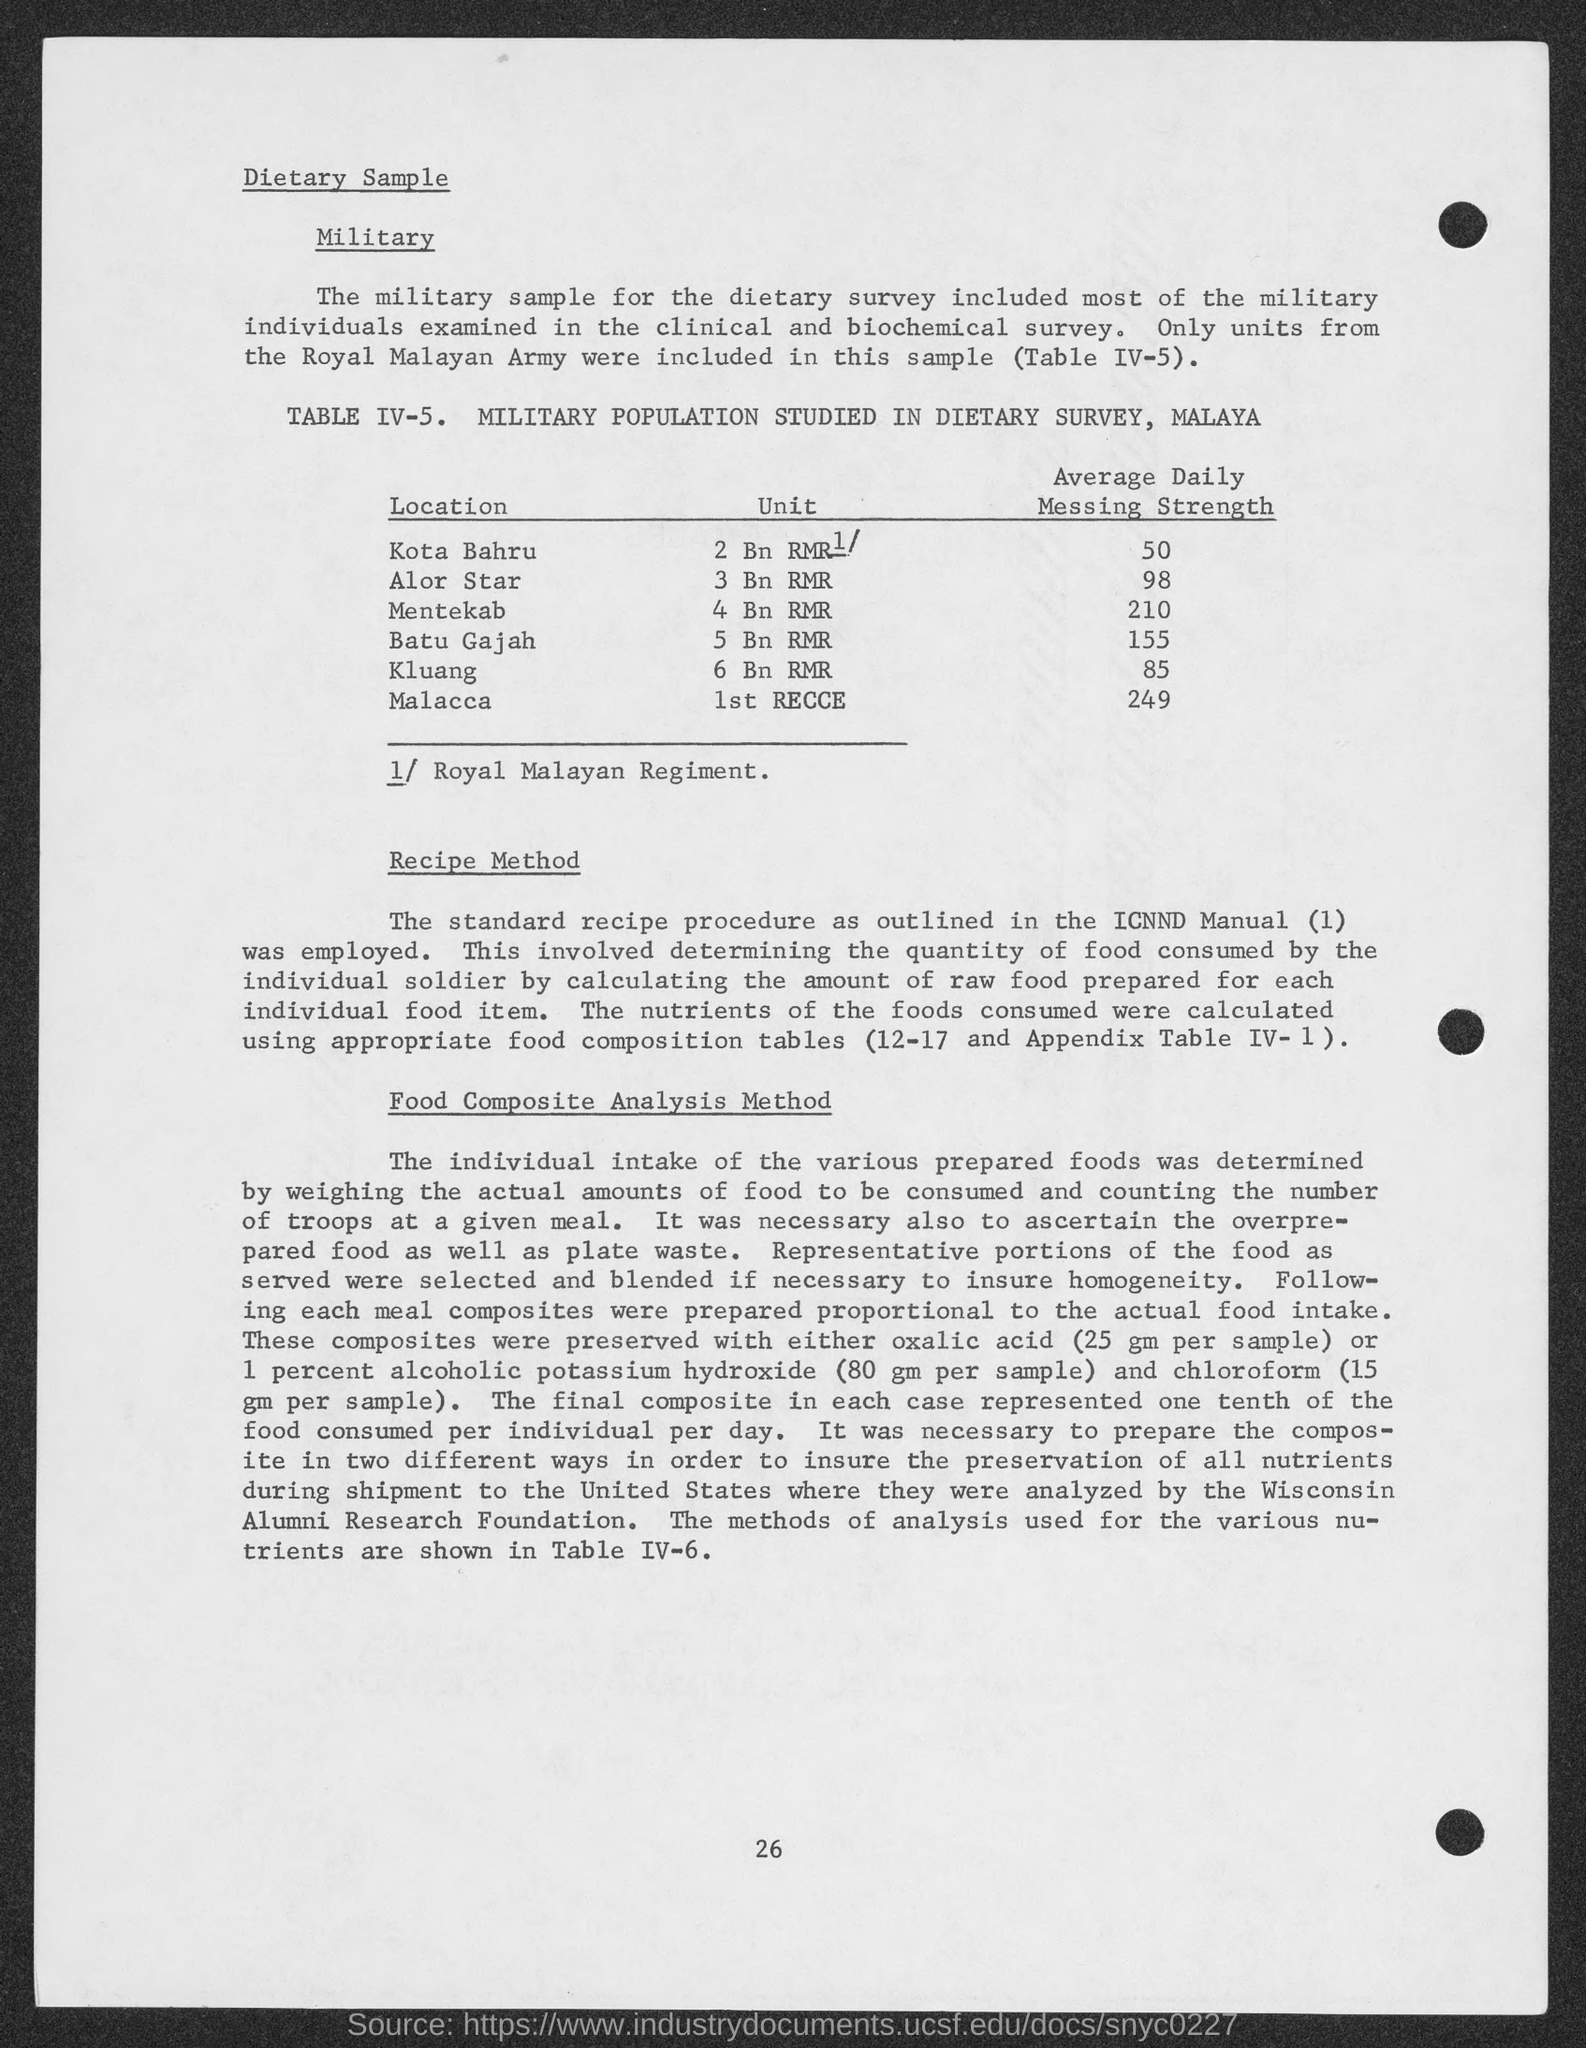Can you explain why some locations have significantly different messing strengths? The different Average Daily Messing Strengths across locations could be influenced by several factors including the size of the military unit, the specific needs based on the local conditions, and operational requirements of each location. 